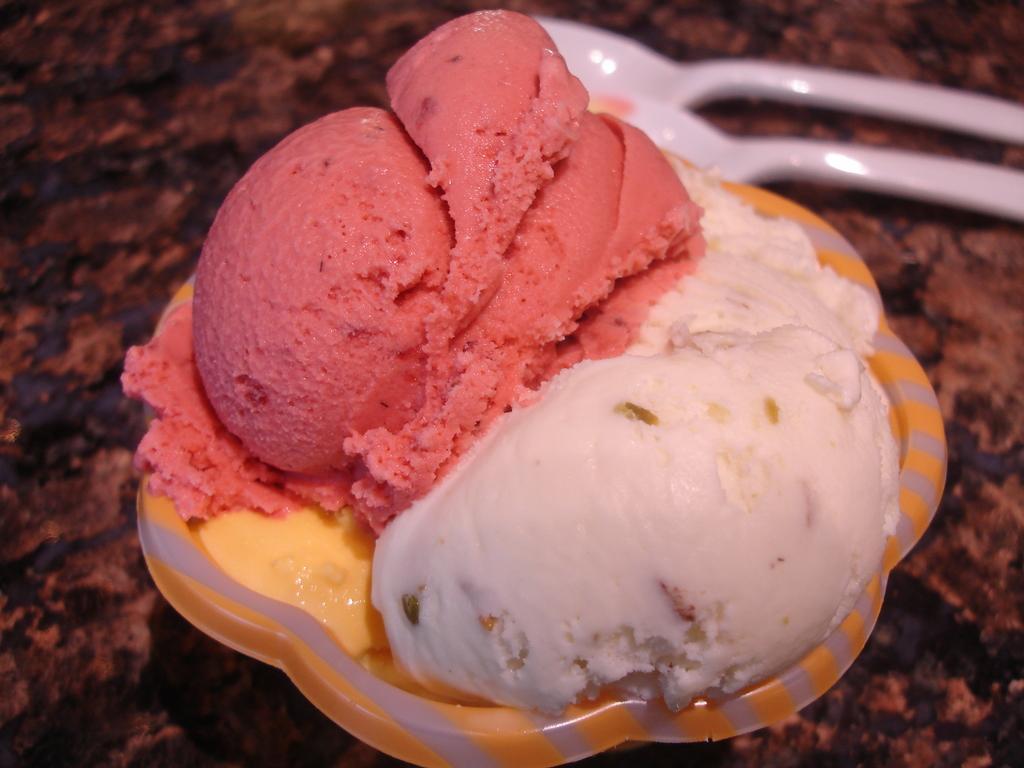In one or two sentences, can you explain what this image depicts? As we can see in the image there is a table. On table there is a bowl and white color spoons. In bowl there is an ice cream. 